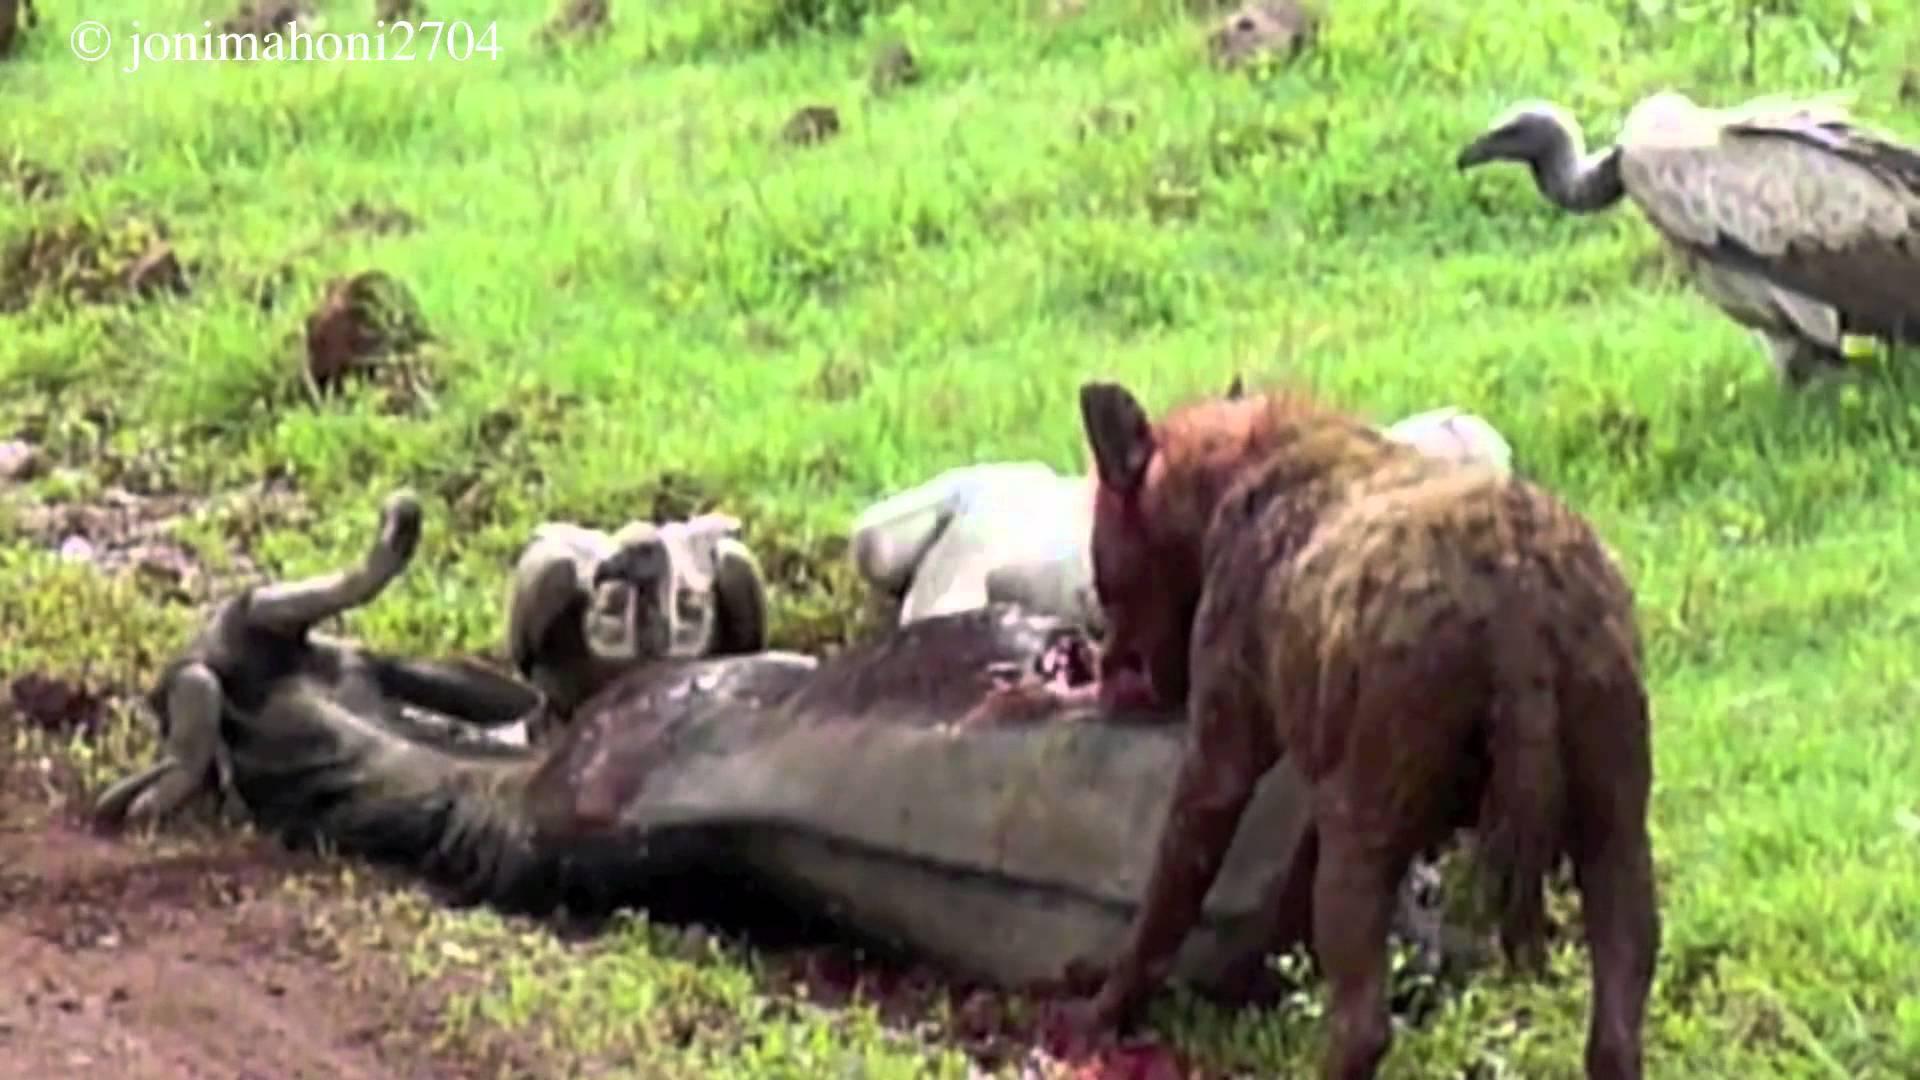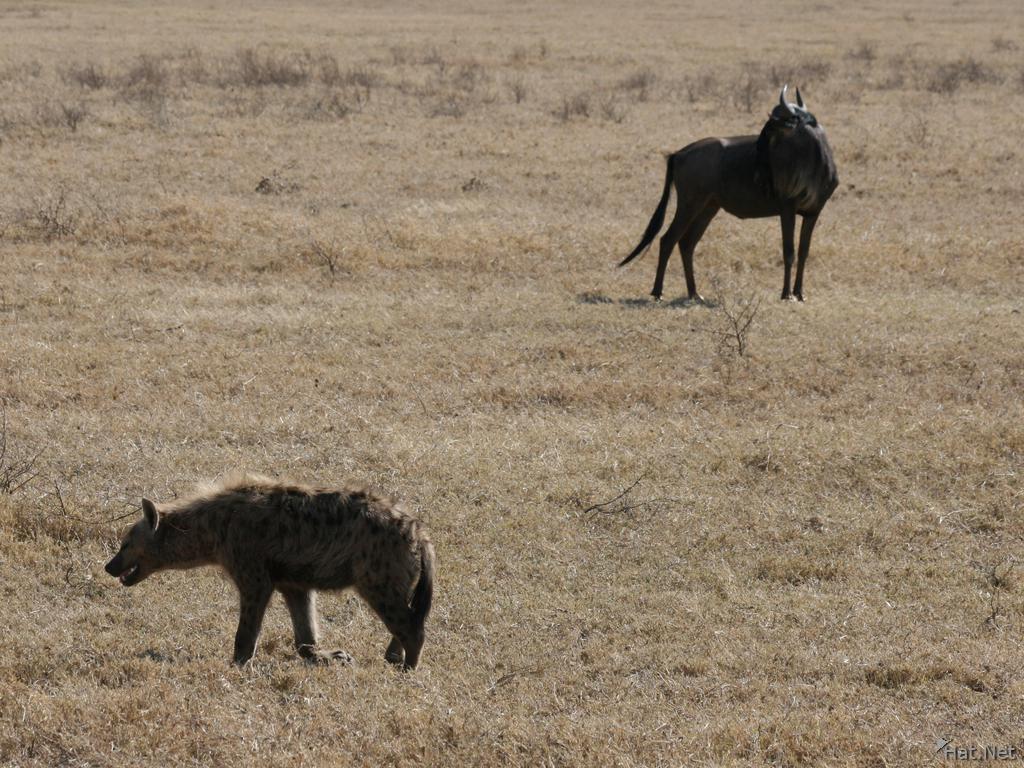The first image is the image on the left, the second image is the image on the right. Examine the images to the left and right. Is the description "The right image contains no more than two hyenas." accurate? Answer yes or no. Yes. The first image is the image on the left, the second image is the image on the right. Evaluate the accuracy of this statement regarding the images: "The left image shows one hyena facing away from the camera and standing next to a downed horned animal that is larger than the hyena.". Is it true? Answer yes or no. Yes. 